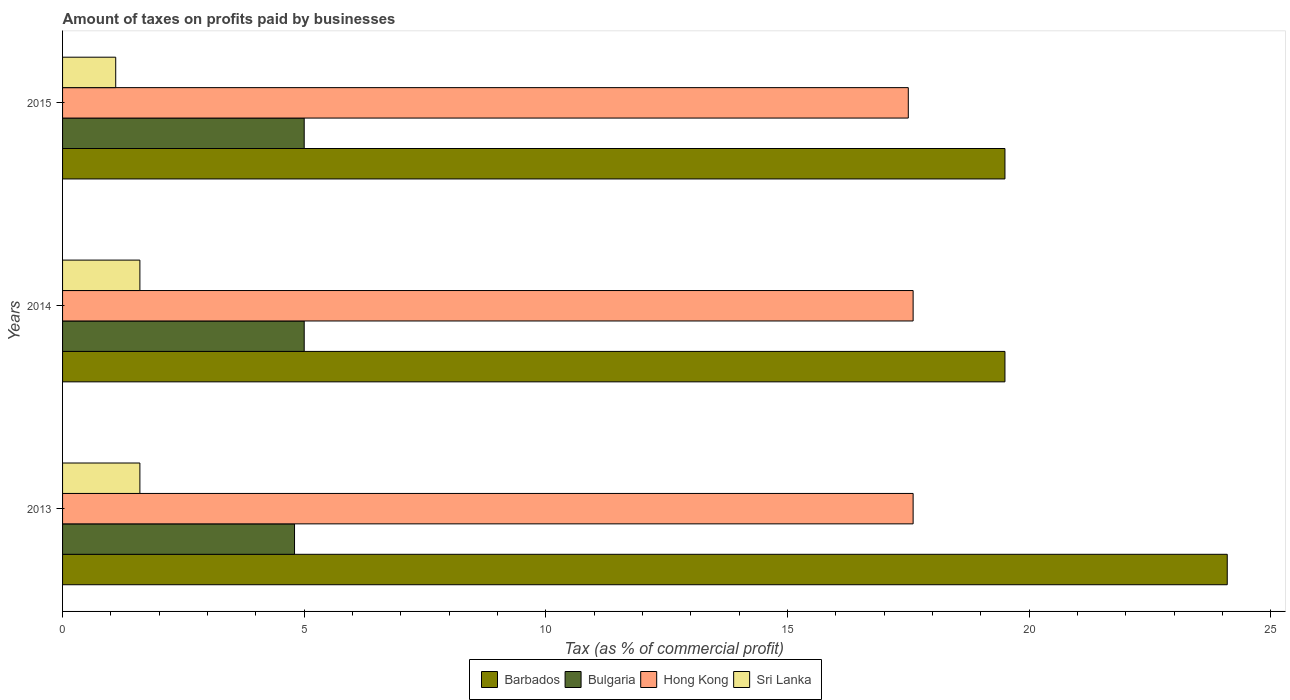How many bars are there on the 1st tick from the bottom?
Provide a succinct answer. 4. What is the label of the 1st group of bars from the top?
Keep it short and to the point. 2015. In how many cases, is the number of bars for a given year not equal to the number of legend labels?
Provide a succinct answer. 0. In which year was the percentage of taxes paid by businesses in Hong Kong maximum?
Your answer should be very brief. 2013. In which year was the percentage of taxes paid by businesses in Barbados minimum?
Your answer should be compact. 2014. What is the total percentage of taxes paid by businesses in Hong Kong in the graph?
Ensure brevity in your answer.  52.7. What is the difference between the percentage of taxes paid by businesses in Sri Lanka in 2013 and that in 2014?
Offer a terse response. 0. What is the difference between the percentage of taxes paid by businesses in Sri Lanka in 2014 and the percentage of taxes paid by businesses in Hong Kong in 2013?
Keep it short and to the point. -16. What is the average percentage of taxes paid by businesses in Sri Lanka per year?
Make the answer very short. 1.43. In how many years, is the percentage of taxes paid by businesses in Sri Lanka greater than 2 %?
Your response must be concise. 0. Is the difference between the percentage of taxes paid by businesses in Hong Kong in 2014 and 2015 greater than the difference between the percentage of taxes paid by businesses in Sri Lanka in 2014 and 2015?
Offer a very short reply. No. Is it the case that in every year, the sum of the percentage of taxes paid by businesses in Sri Lanka and percentage of taxes paid by businesses in Hong Kong is greater than the sum of percentage of taxes paid by businesses in Barbados and percentage of taxes paid by businesses in Bulgaria?
Your answer should be very brief. Yes. What does the 1st bar from the top in 2015 represents?
Ensure brevity in your answer.  Sri Lanka. What does the 3rd bar from the bottom in 2014 represents?
Your response must be concise. Hong Kong. How many bars are there?
Provide a short and direct response. 12. What is the difference between two consecutive major ticks on the X-axis?
Provide a succinct answer. 5. How many legend labels are there?
Provide a short and direct response. 4. How are the legend labels stacked?
Offer a terse response. Horizontal. What is the title of the graph?
Give a very brief answer. Amount of taxes on profits paid by businesses. Does "Kiribati" appear as one of the legend labels in the graph?
Ensure brevity in your answer.  No. What is the label or title of the X-axis?
Make the answer very short. Tax (as % of commercial profit). What is the label or title of the Y-axis?
Keep it short and to the point. Years. What is the Tax (as % of commercial profit) in Barbados in 2013?
Offer a very short reply. 24.1. What is the Tax (as % of commercial profit) in Hong Kong in 2013?
Ensure brevity in your answer.  17.6. What is the Tax (as % of commercial profit) of Sri Lanka in 2013?
Offer a very short reply. 1.6. What is the Tax (as % of commercial profit) of Hong Kong in 2014?
Make the answer very short. 17.6. What is the Tax (as % of commercial profit) of Sri Lanka in 2014?
Provide a short and direct response. 1.6. What is the Tax (as % of commercial profit) of Bulgaria in 2015?
Keep it short and to the point. 5. What is the Tax (as % of commercial profit) in Hong Kong in 2015?
Provide a succinct answer. 17.5. Across all years, what is the maximum Tax (as % of commercial profit) of Barbados?
Offer a very short reply. 24.1. Across all years, what is the maximum Tax (as % of commercial profit) in Bulgaria?
Offer a terse response. 5. Across all years, what is the maximum Tax (as % of commercial profit) in Hong Kong?
Ensure brevity in your answer.  17.6. Across all years, what is the minimum Tax (as % of commercial profit) of Barbados?
Make the answer very short. 19.5. Across all years, what is the minimum Tax (as % of commercial profit) of Bulgaria?
Offer a terse response. 4.8. Across all years, what is the minimum Tax (as % of commercial profit) in Hong Kong?
Your response must be concise. 17.5. What is the total Tax (as % of commercial profit) of Barbados in the graph?
Provide a succinct answer. 63.1. What is the total Tax (as % of commercial profit) in Bulgaria in the graph?
Keep it short and to the point. 14.8. What is the total Tax (as % of commercial profit) in Hong Kong in the graph?
Ensure brevity in your answer.  52.7. What is the difference between the Tax (as % of commercial profit) in Barbados in 2013 and that in 2014?
Your answer should be very brief. 4.6. What is the difference between the Tax (as % of commercial profit) of Bulgaria in 2013 and that in 2014?
Make the answer very short. -0.2. What is the difference between the Tax (as % of commercial profit) of Hong Kong in 2013 and that in 2014?
Your response must be concise. 0. What is the difference between the Tax (as % of commercial profit) in Sri Lanka in 2013 and that in 2014?
Your answer should be very brief. 0. What is the difference between the Tax (as % of commercial profit) of Barbados in 2013 and that in 2015?
Your answer should be compact. 4.6. What is the difference between the Tax (as % of commercial profit) of Hong Kong in 2013 and that in 2015?
Give a very brief answer. 0.1. What is the difference between the Tax (as % of commercial profit) in Barbados in 2014 and that in 2015?
Your response must be concise. 0. What is the difference between the Tax (as % of commercial profit) of Sri Lanka in 2014 and that in 2015?
Provide a succinct answer. 0.5. What is the difference between the Tax (as % of commercial profit) of Barbados in 2013 and the Tax (as % of commercial profit) of Hong Kong in 2014?
Ensure brevity in your answer.  6.5. What is the difference between the Tax (as % of commercial profit) of Bulgaria in 2013 and the Tax (as % of commercial profit) of Sri Lanka in 2014?
Your response must be concise. 3.2. What is the difference between the Tax (as % of commercial profit) of Hong Kong in 2013 and the Tax (as % of commercial profit) of Sri Lanka in 2014?
Provide a short and direct response. 16. What is the difference between the Tax (as % of commercial profit) of Barbados in 2013 and the Tax (as % of commercial profit) of Bulgaria in 2015?
Keep it short and to the point. 19.1. What is the difference between the Tax (as % of commercial profit) of Barbados in 2013 and the Tax (as % of commercial profit) of Sri Lanka in 2015?
Give a very brief answer. 23. What is the difference between the Tax (as % of commercial profit) of Bulgaria in 2013 and the Tax (as % of commercial profit) of Hong Kong in 2015?
Keep it short and to the point. -12.7. What is the difference between the Tax (as % of commercial profit) in Bulgaria in 2013 and the Tax (as % of commercial profit) in Sri Lanka in 2015?
Provide a succinct answer. 3.7. What is the difference between the Tax (as % of commercial profit) of Hong Kong in 2013 and the Tax (as % of commercial profit) of Sri Lanka in 2015?
Keep it short and to the point. 16.5. What is the difference between the Tax (as % of commercial profit) in Barbados in 2014 and the Tax (as % of commercial profit) in Bulgaria in 2015?
Keep it short and to the point. 14.5. What is the difference between the Tax (as % of commercial profit) in Barbados in 2014 and the Tax (as % of commercial profit) in Sri Lanka in 2015?
Your answer should be very brief. 18.4. What is the difference between the Tax (as % of commercial profit) in Bulgaria in 2014 and the Tax (as % of commercial profit) in Sri Lanka in 2015?
Ensure brevity in your answer.  3.9. What is the average Tax (as % of commercial profit) of Barbados per year?
Your answer should be very brief. 21.03. What is the average Tax (as % of commercial profit) of Bulgaria per year?
Your response must be concise. 4.93. What is the average Tax (as % of commercial profit) of Hong Kong per year?
Keep it short and to the point. 17.57. What is the average Tax (as % of commercial profit) in Sri Lanka per year?
Your answer should be very brief. 1.43. In the year 2013, what is the difference between the Tax (as % of commercial profit) in Barbados and Tax (as % of commercial profit) in Bulgaria?
Offer a terse response. 19.3. In the year 2013, what is the difference between the Tax (as % of commercial profit) in Barbados and Tax (as % of commercial profit) in Hong Kong?
Provide a short and direct response. 6.5. In the year 2013, what is the difference between the Tax (as % of commercial profit) in Barbados and Tax (as % of commercial profit) in Sri Lanka?
Ensure brevity in your answer.  22.5. In the year 2014, what is the difference between the Tax (as % of commercial profit) in Barbados and Tax (as % of commercial profit) in Bulgaria?
Your response must be concise. 14.5. In the year 2014, what is the difference between the Tax (as % of commercial profit) of Bulgaria and Tax (as % of commercial profit) of Hong Kong?
Ensure brevity in your answer.  -12.6. In the year 2014, what is the difference between the Tax (as % of commercial profit) in Bulgaria and Tax (as % of commercial profit) in Sri Lanka?
Keep it short and to the point. 3.4. In the year 2014, what is the difference between the Tax (as % of commercial profit) in Hong Kong and Tax (as % of commercial profit) in Sri Lanka?
Your response must be concise. 16. In the year 2015, what is the difference between the Tax (as % of commercial profit) of Barbados and Tax (as % of commercial profit) of Bulgaria?
Offer a terse response. 14.5. In the year 2015, what is the difference between the Tax (as % of commercial profit) in Barbados and Tax (as % of commercial profit) in Sri Lanka?
Give a very brief answer. 18.4. In the year 2015, what is the difference between the Tax (as % of commercial profit) of Bulgaria and Tax (as % of commercial profit) of Hong Kong?
Your answer should be compact. -12.5. In the year 2015, what is the difference between the Tax (as % of commercial profit) of Hong Kong and Tax (as % of commercial profit) of Sri Lanka?
Your answer should be compact. 16.4. What is the ratio of the Tax (as % of commercial profit) of Barbados in 2013 to that in 2014?
Offer a terse response. 1.24. What is the ratio of the Tax (as % of commercial profit) in Barbados in 2013 to that in 2015?
Offer a terse response. 1.24. What is the ratio of the Tax (as % of commercial profit) in Hong Kong in 2013 to that in 2015?
Keep it short and to the point. 1.01. What is the ratio of the Tax (as % of commercial profit) in Sri Lanka in 2013 to that in 2015?
Provide a succinct answer. 1.45. What is the ratio of the Tax (as % of commercial profit) in Barbados in 2014 to that in 2015?
Offer a very short reply. 1. What is the ratio of the Tax (as % of commercial profit) in Hong Kong in 2014 to that in 2015?
Give a very brief answer. 1.01. What is the ratio of the Tax (as % of commercial profit) of Sri Lanka in 2014 to that in 2015?
Your answer should be compact. 1.45. What is the difference between the highest and the second highest Tax (as % of commercial profit) of Bulgaria?
Provide a succinct answer. 0. What is the difference between the highest and the second highest Tax (as % of commercial profit) of Hong Kong?
Your response must be concise. 0. What is the difference between the highest and the lowest Tax (as % of commercial profit) of Bulgaria?
Provide a short and direct response. 0.2. What is the difference between the highest and the lowest Tax (as % of commercial profit) of Sri Lanka?
Your answer should be compact. 0.5. 